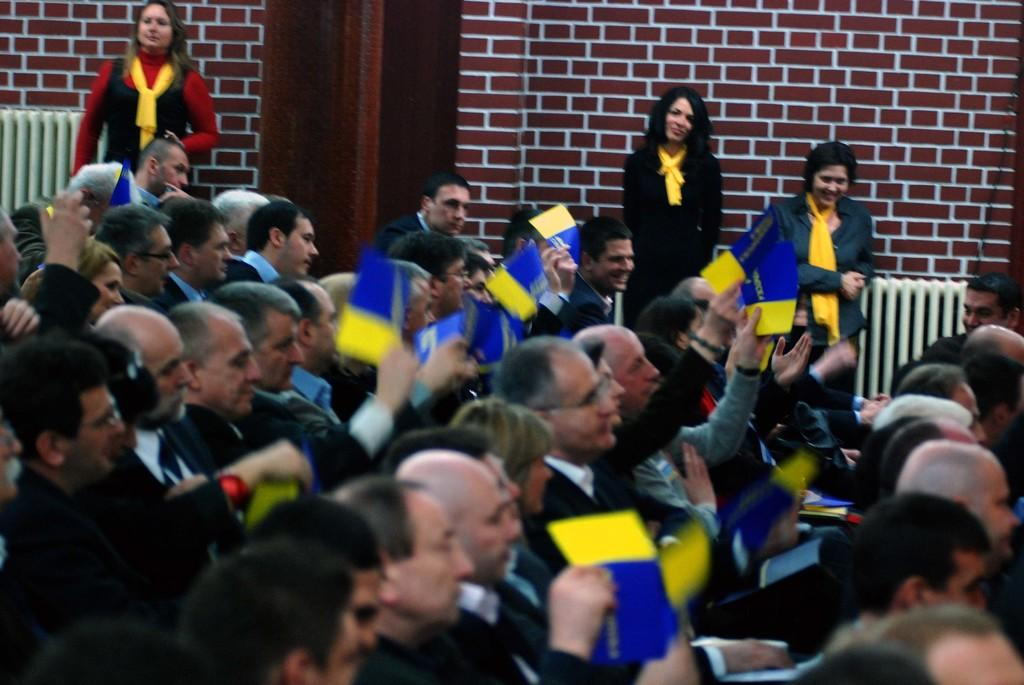What are the people in the image doing? There is a group of people sitting in the image, and they are holding items. How many people are standing beside the sitting group? There are three people standing beside the sitting group. What can be seen in the background of the image? There is a brick wall in the image. What page of the book are the people reading in the image? There is no book present in the image, so it is not possible to determine which page they might be reading. 